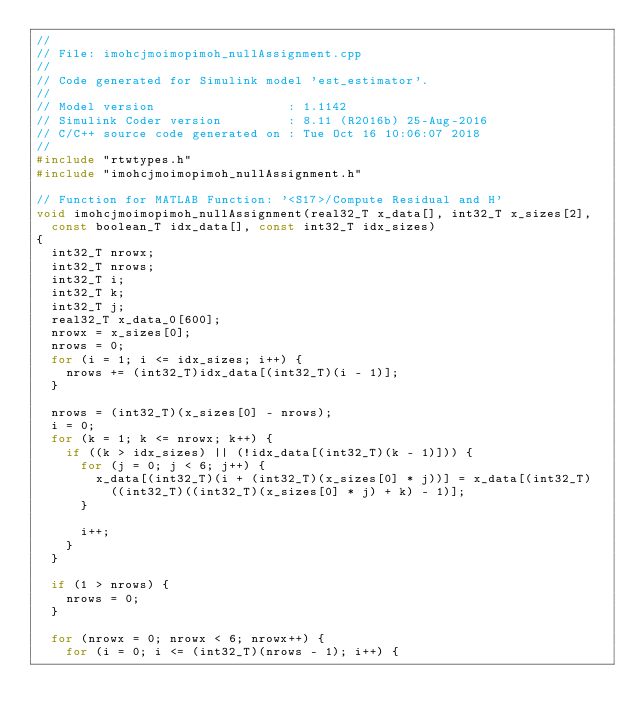Convert code to text. <code><loc_0><loc_0><loc_500><loc_500><_C++_>//
// File: imohcjmoimopimoh_nullAssignment.cpp
//
// Code generated for Simulink model 'est_estimator'.
//
// Model version                  : 1.1142
// Simulink Coder version         : 8.11 (R2016b) 25-Aug-2016
// C/C++ source code generated on : Tue Oct 16 10:06:07 2018
//
#include "rtwtypes.h"
#include "imohcjmoimopimoh_nullAssignment.h"

// Function for MATLAB Function: '<S17>/Compute Residual and H'
void imohcjmoimopimoh_nullAssignment(real32_T x_data[], int32_T x_sizes[2],
  const boolean_T idx_data[], const int32_T idx_sizes)
{
  int32_T nrowx;
  int32_T nrows;
  int32_T i;
  int32_T k;
  int32_T j;
  real32_T x_data_0[600];
  nrowx = x_sizes[0];
  nrows = 0;
  for (i = 1; i <= idx_sizes; i++) {
    nrows += (int32_T)idx_data[(int32_T)(i - 1)];
  }

  nrows = (int32_T)(x_sizes[0] - nrows);
  i = 0;
  for (k = 1; k <= nrowx; k++) {
    if ((k > idx_sizes) || (!idx_data[(int32_T)(k - 1)])) {
      for (j = 0; j < 6; j++) {
        x_data[(int32_T)(i + (int32_T)(x_sizes[0] * j))] = x_data[(int32_T)
          ((int32_T)((int32_T)(x_sizes[0] * j) + k) - 1)];
      }

      i++;
    }
  }

  if (1 > nrows) {
    nrows = 0;
  }

  for (nrowx = 0; nrowx < 6; nrowx++) {
    for (i = 0; i <= (int32_T)(nrows - 1); i++) {</code> 